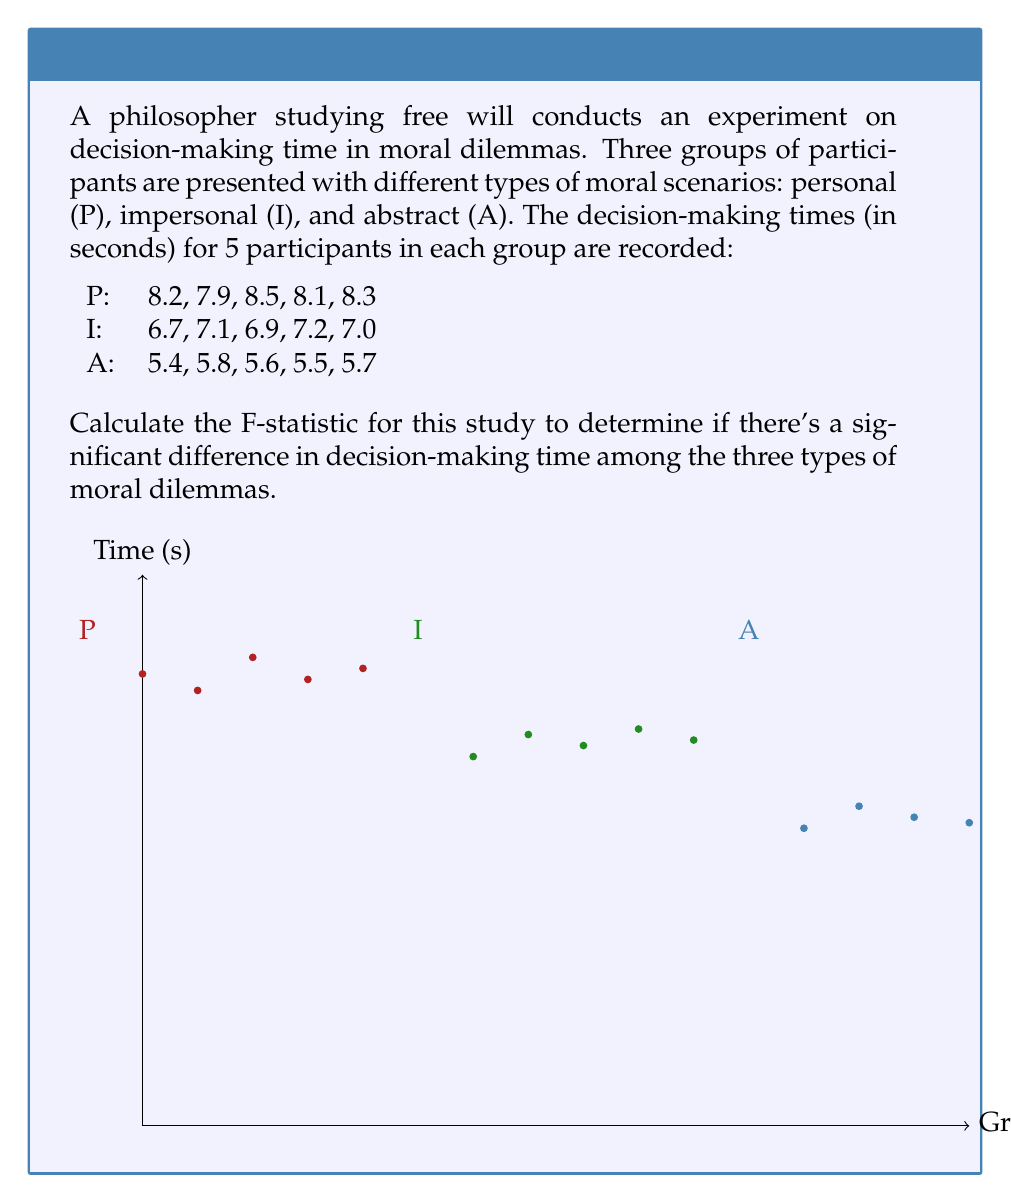Can you solve this math problem? To calculate the F-statistic, we need to follow these steps:

1. Calculate the grand mean:
   $$\bar{X} = \frac{\sum_{i=1}^{n} X_i}{n} = \frac{91.9}{15} = 6.13$$

2. Calculate the means for each group:
   $$\bar{X}_P = 8.2, \bar{X}_I = 6.98, \bar{X}_A = 5.6$$

3. Calculate the Sum of Squares Between (SSB):
   $$SSB = \sum_{i=1}^{k} n_i(\bar{X}_i - \bar{X})^2$$
   $$SSB = 5(8.2 - 6.13)^2 + 5(6.98 - 6.13)^2 + 5(5.6 - 6.13)^2 = 21.5228$$

4. Calculate the Sum of Squares Within (SSW):
   $$SSW = \sum_{i=1}^{k} \sum_{j=1}^{n_i} (X_{ij} - \bar{X}_i)^2$$
   $$SSW = 0.2680 + 0.1880 + 0.1280 = 0.5840$$

5. Calculate the degrees of freedom:
   $$df_{between} = k - 1 = 3 - 1 = 2$$
   $$df_{within} = N - k = 15 - 3 = 12$$

6. Calculate the Mean Square Between (MSB) and Mean Square Within (MSW):
   $$MSB = \frac{SSB}{df_{between}} = \frac{21.5228}{2} = 10.7614$$
   $$MSW = \frac{SSW}{df_{within}} = \frac{0.5840}{12} = 0.0487$$

7. Calculate the F-statistic:
   $$F = \frac{MSB}{MSW} = \frac{10.7614}{0.0487} = 221.0144$$
Answer: $F = 221.01$ 